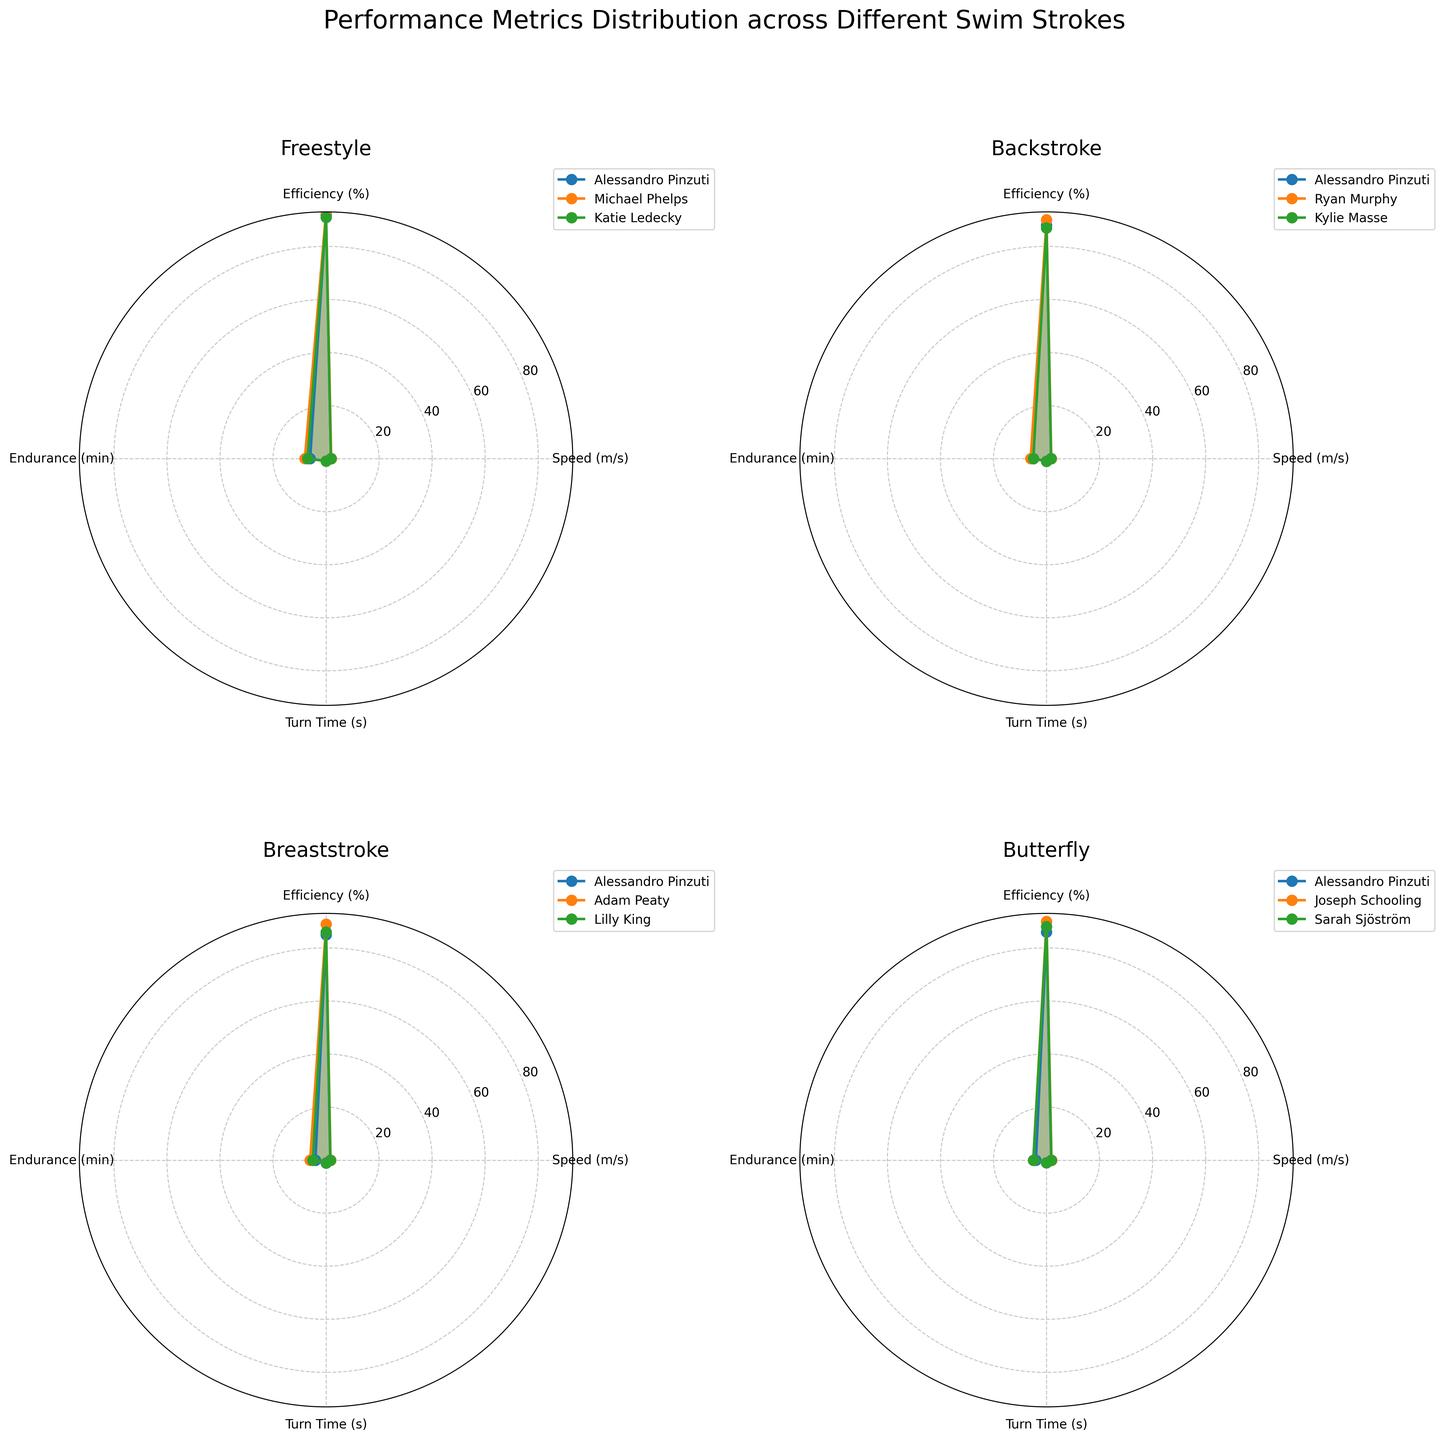Which swimmer has the highest speed in Freestyle stroke? Look at the Freestyle subplot and compare the maximum speed values for Alessandro Pinzuti, Michael Phelps, and Katie Ledecky. Michael Phelps has the highest speed of 1.95 m/s.
Answer: Michael Phelps What is the average efficiency of swimmers in the Backstroke? Identify the efficiency values of Alessandro Pinzuti, Ryan Murphy, and Kylie Masse in the Backstroke subplot. Sum these values and divide by the number of swimmers (88 + 90 + 87) / 3.
Answer: 88.33% Is Alessandro Pinzuti more efficient in Breaststroke or Butterfly? Compare Alessandro Pinzuti's efficiency in Breaststroke and Butterfly. In Breaststroke, his efficiency is 85%, and in Butterfly, it's 86%.
Answer: Butterfly How much longer is Adam Peaty's turn time compared to Alessandro Pinzuti's in Breaststroke? Locate the turn times for Adam Peaty and Alessandro Pinzuti in Breaststroke. Adam Peaty's turn time is 1.0 s, and Alessandro Pinzuti's turn time is 1.05 s. The difference is 1.05 - 1.00.
Answer: 0.05 s Which stroke has the highest average endurance for all swimmers? Calculate the endurance for each stroke by averaging the values of all swimmers in each stroke. Freestyle (6 + 8 + 7) / 3 = 7. Backstroke (5 + 6 + 5) / 3 = 5.33. Breaststroke (4 + 6 + 5) / 3 = 5. Butterfly (4 + 5 + 5) / 3 = 4.67.
Answer: Freestyle In which stroke is Alessandro Pinzuti closest in performance to the top swimmer in terms of speed? Compare Alessandro Pinzuti's speeds in Freestyle (1.85), Backstroke (1.70), Breaststroke (1.58), and Butterfly (1.75) to the top swimmer's speeds in each stroke. The smallest difference is in Backstroke (top swimmer Ryan Murphy has 1.80, so difference is 1.80 - 1.70 = 0.10).
Answer: Backstroke Which metric shows the most significant variation across swimmers in Butterfly stroke? Assess the spread of values for speed, efficiency, endurance, and turn time in Butterfly. Speed ranges from 1.75 to 1.88, efficiency from 86 to 90, endurance from 4 to 5, and turn time from 0.95 to 0.97. Speed has the largest range (0.13).
Answer: Speed What is the combined turn time for all swimmers in Freestyle? Add the turn times of Alessandro Pinzuti, Michael Phelps, and Katie Ledecky in Freestyle. The sum is 0.92 + 0.89 + 0.91.
Answer: 2.72 s 